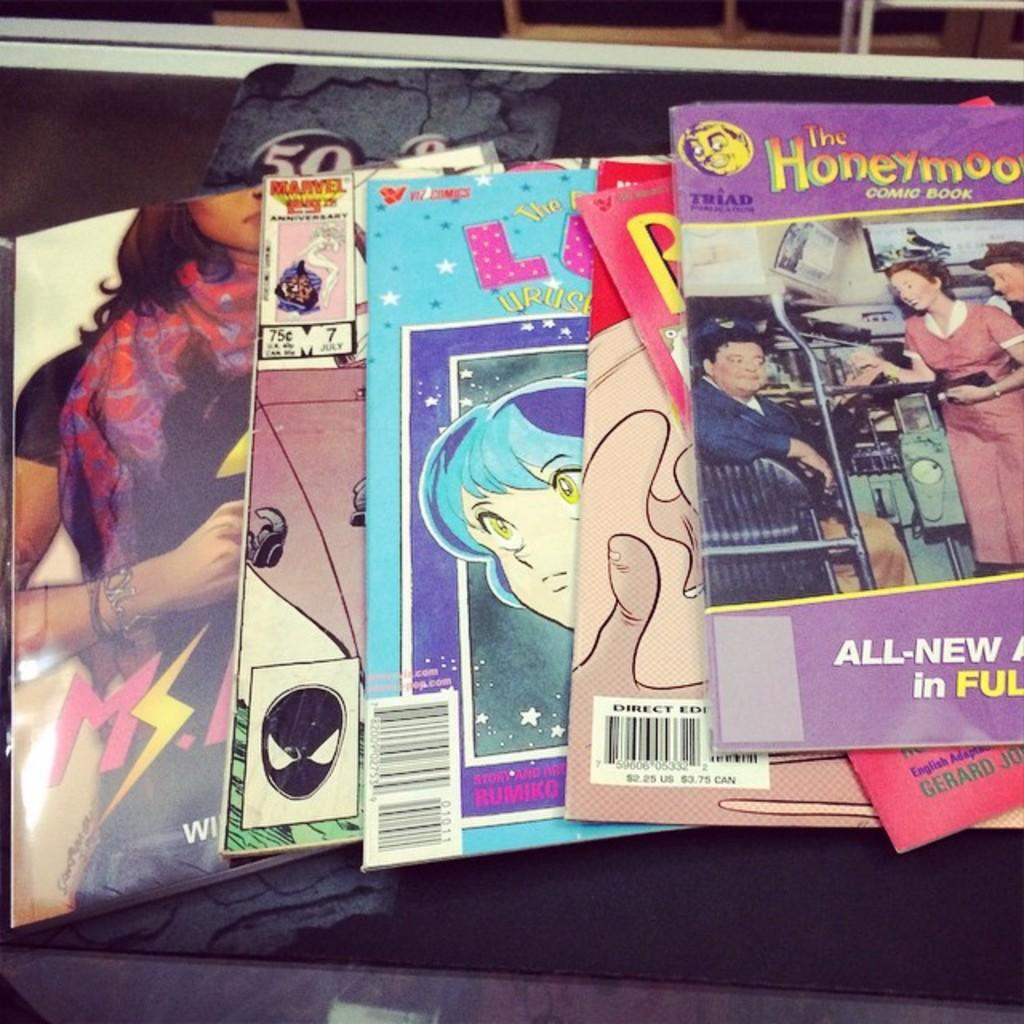<image>
Describe the image concisely. A selection of comic books including one called 'The honeymooners'. 